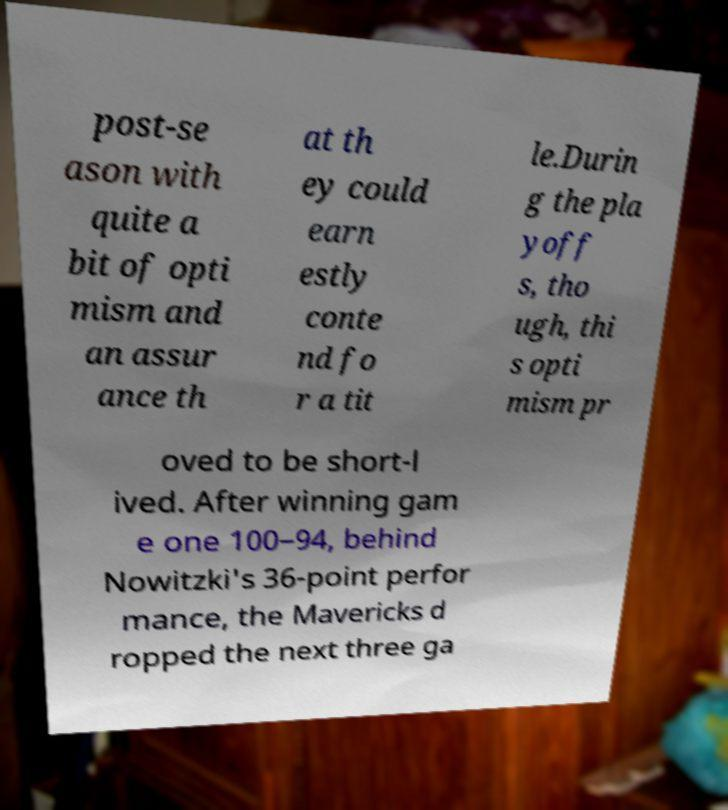Can you accurately transcribe the text from the provided image for me? post-se ason with quite a bit of opti mism and an assur ance th at th ey could earn estly conte nd fo r a tit le.Durin g the pla yoff s, tho ugh, thi s opti mism pr oved to be short-l ived. After winning gam e one 100–94, behind Nowitzki's 36-point perfor mance, the Mavericks d ropped the next three ga 